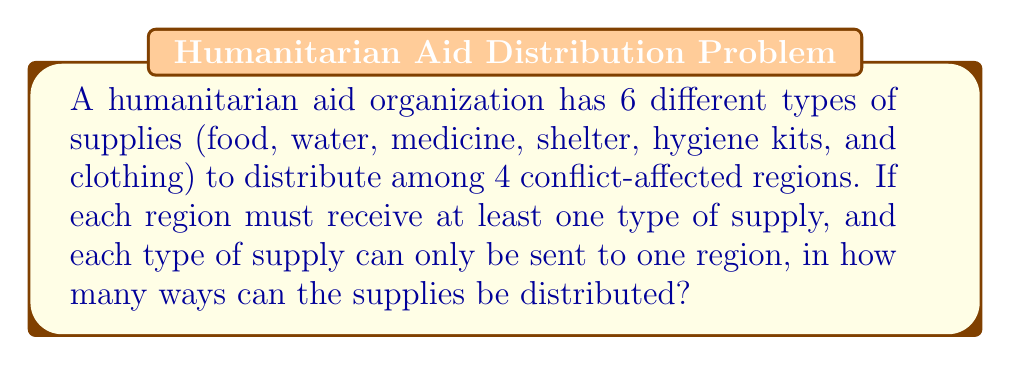Solve this math problem. This problem can be solved using the concept of permutations with restrictions. Let's approach this step-by-step:

1) First, we need to understand that this is a surjective function problem, where we are distributing 6 supplies (domain) to 4 regions (codomain), and each region must receive at least one supply.

2) We can use the formula for the number of surjective functions from a set of $m$ elements to a set of $n$ elements:

   $$S(m,n) = n! \cdot \sum_{k=0}^n (-1)^k \binom{n}{k} (n-k)^m$$

   Where $m = 6$ (supplies) and $n = 4$ (regions)

3) Let's calculate each part of the formula:

   $$S(6,4) = 4! \cdot \sum_{k=0}^4 (-1)^k \binom{4}{k} (4-k)^6$$

4) Expand the summation:
   
   $$4! \cdot [\binom{4}{0}4^6 - \binom{4}{1}3^6 + \binom{4}{2}2^6 - \binom{4}{3}1^6 + \binom{4}{4}0^6]$$

5) Calculate the binomial coefficients:
   
   $$24 \cdot [1 \cdot 4096 - 4 \cdot 729 + 6 \cdot 64 - 4 \cdot 1 + 1 \cdot 0]$$

6) Simplify:
   
   $$24 \cdot [4096 - 2916 + 384 - 4 + 0] = 24 \cdot 1560 = 37,440$$

Therefore, there are 37,440 ways to distribute the supplies.
Answer: 37,440 